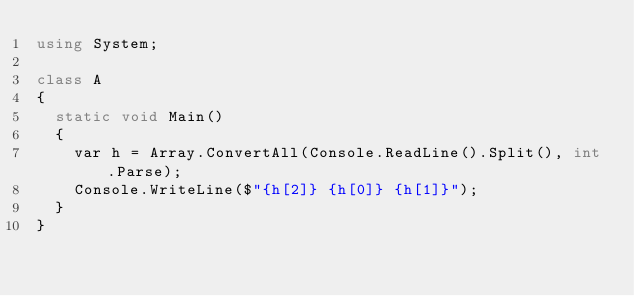Convert code to text. <code><loc_0><loc_0><loc_500><loc_500><_C#_>using System;

class A
{
	static void Main()
	{
		var h = Array.ConvertAll(Console.ReadLine().Split(), int.Parse);
		Console.WriteLine($"{h[2]} {h[0]} {h[1]}");
	}
}
</code> 